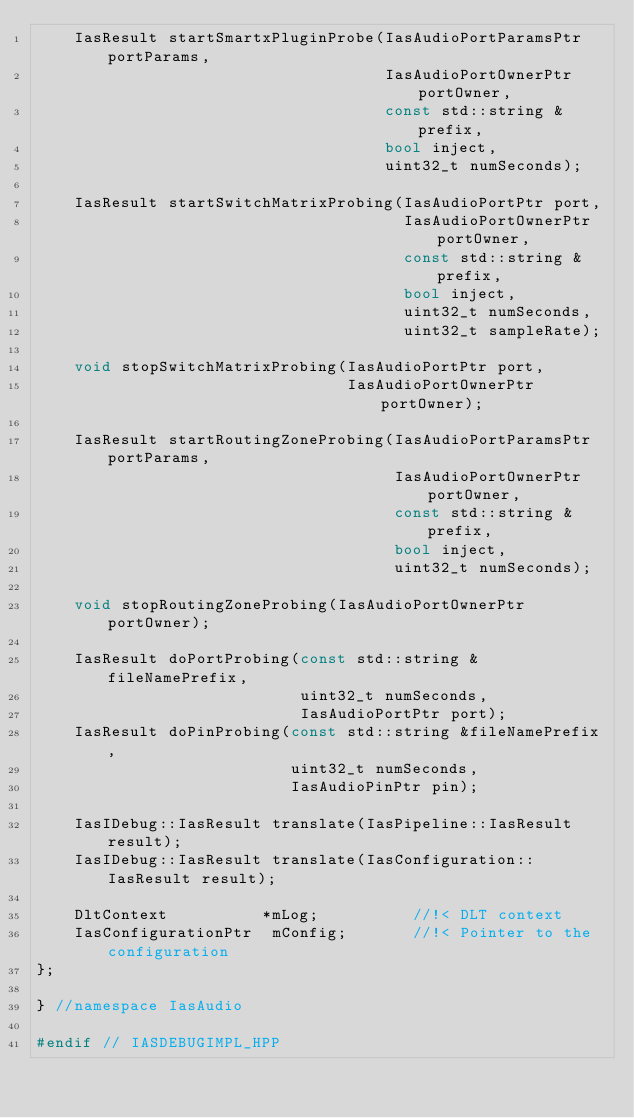Convert code to text. <code><loc_0><loc_0><loc_500><loc_500><_C++_>    IasResult startSmartxPluginProbe(IasAudioPortParamsPtr portParams,
                                     IasAudioPortOwnerPtr portOwner,
                                     const std::string &prefix,
                                     bool inject,
                                     uint32_t numSeconds);

    IasResult startSwitchMatrixProbing(IasAudioPortPtr port,
                                       IasAudioPortOwnerPtr portOwner,
                                       const std::string &prefix,
                                       bool inject,
                                       uint32_t numSeconds,
                                       uint32_t sampleRate);

    void stopSwitchMatrixProbing(IasAudioPortPtr port,
                                 IasAudioPortOwnerPtr portOwner);

    IasResult startRoutingZoneProbing(IasAudioPortParamsPtr portParams,
                                      IasAudioPortOwnerPtr portOwner,
                                      const std::string &prefix,
                                      bool inject,
                                      uint32_t numSeconds);

    void stopRoutingZoneProbing(IasAudioPortOwnerPtr portOwner);

    IasResult doPortProbing(const std::string &fileNamePrefix,
                            uint32_t numSeconds,
                            IasAudioPortPtr port);
    IasResult doPinProbing(const std::string &fileNamePrefix,
                           uint32_t numSeconds,
                           IasAudioPinPtr pin);

    IasIDebug::IasResult translate(IasPipeline::IasResult result);
    IasIDebug::IasResult translate(IasConfiguration::IasResult result);

    DltContext          *mLog;          //!< DLT context
    IasConfigurationPtr  mConfig;       //!< Pointer to the configuration
};

} //namespace IasAudio

#endif // IASDEBUGIMPL_HPP
</code> 